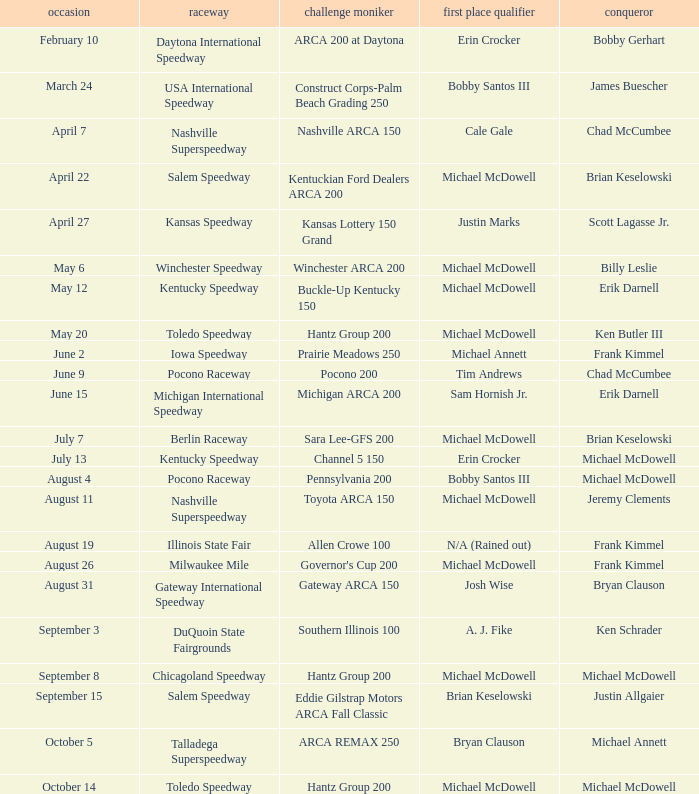Tell me the pole winner of may 12 Michael McDowell. 